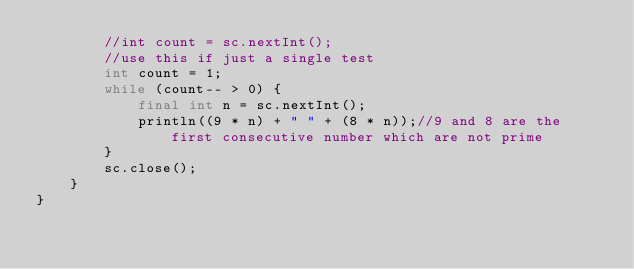Convert code to text. <code><loc_0><loc_0><loc_500><loc_500><_Java_>        //int count = sc.nextInt();
        //use this if just a single test
        int count = 1;
        while (count-- > 0) {
            final int n = sc.nextInt();
            println((9 * n) + " " + (8 * n));//9 and 8 are the first consecutive number which are not prime
        }
        sc.close();
    }
}
</code> 